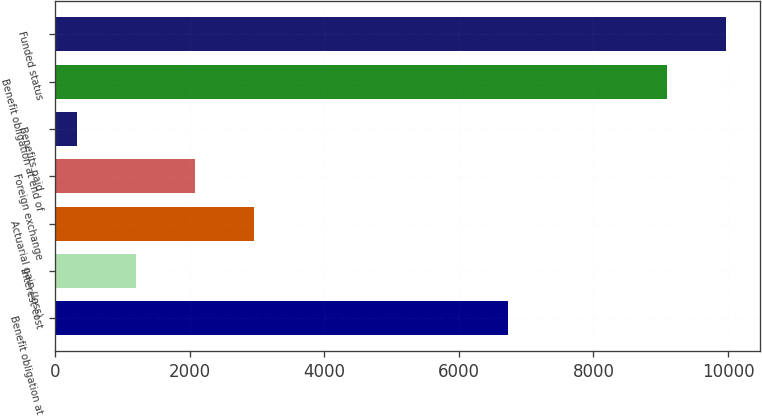<chart> <loc_0><loc_0><loc_500><loc_500><bar_chart><fcel>Benefit obligation at<fcel>Interest cost<fcel>Actuarial gain (loss)<fcel>Foreign exchange<fcel>Benefits paid<fcel>Benefit obligation at end of<fcel>Funded status<nl><fcel>6736<fcel>1194.6<fcel>2949.8<fcel>2072.2<fcel>317<fcel>9093<fcel>9970.6<nl></chart> 